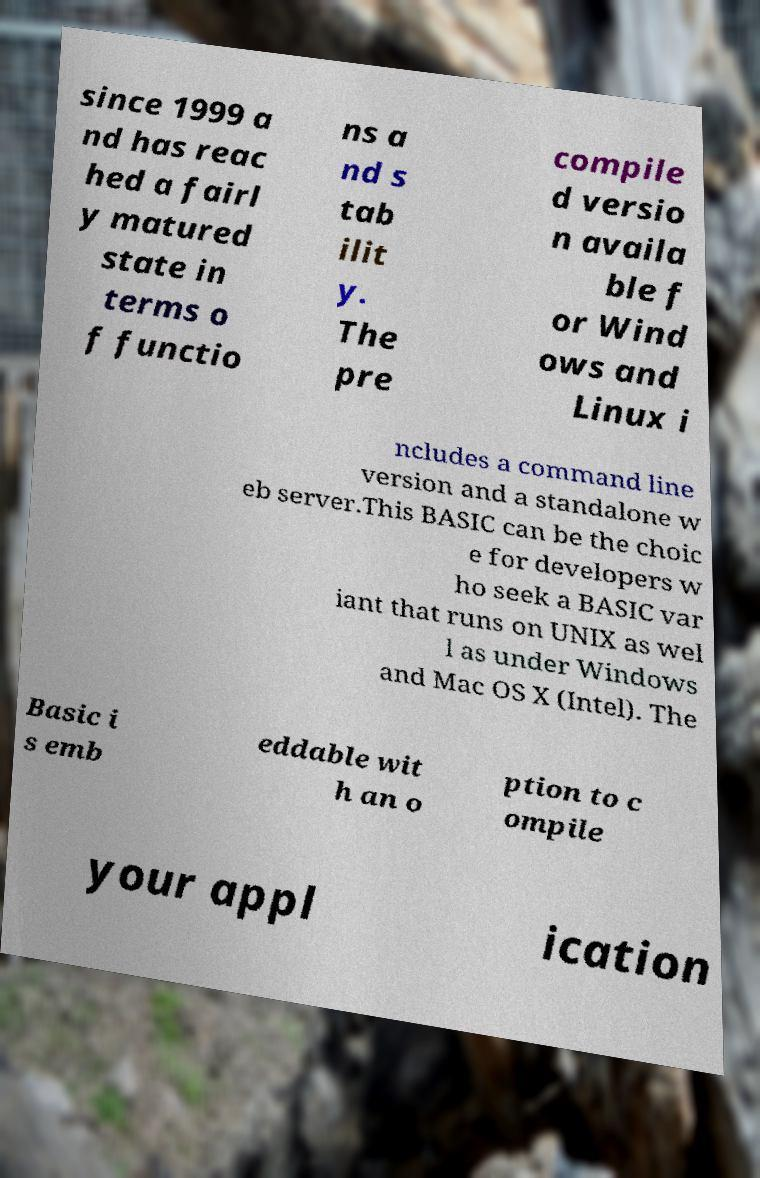There's text embedded in this image that I need extracted. Can you transcribe it verbatim? since 1999 a nd has reac hed a fairl y matured state in terms o f functio ns a nd s tab ilit y. The pre compile d versio n availa ble f or Wind ows and Linux i ncludes a command line version and a standalone w eb server.This BASIC can be the choic e for developers w ho seek a BASIC var iant that runs on UNIX as wel l as under Windows and Mac OS X (Intel). The Basic i s emb eddable wit h an o ption to c ompile your appl ication 